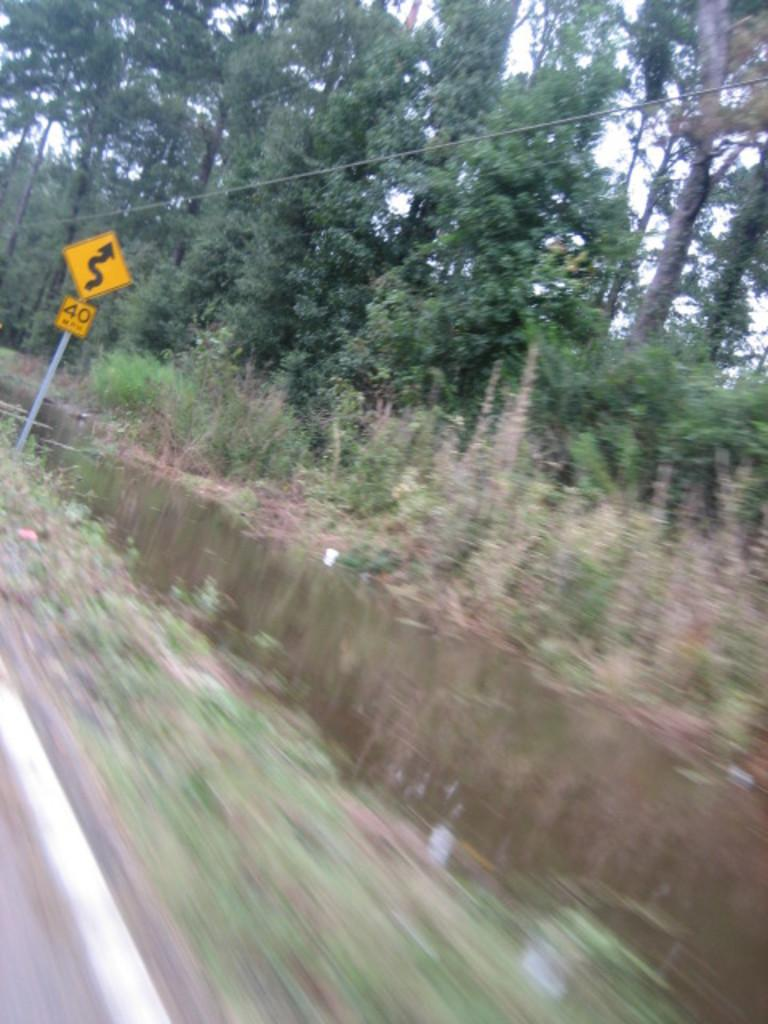What can be seen in the image that is related to a natural resource? There is water visible in the image. What is located on the left side of the image? There is a signboard with text on the left side of the image. What type of vegetation can be seen in the background of the image? There are trees in the background of the image. What is visible in the background of the image besides the trees? The sky is visible in the background of the image. How are the eggs distributed in the image? There are no eggs present in the image. What type of shock can be seen in the image? There is no shock present in the image. 